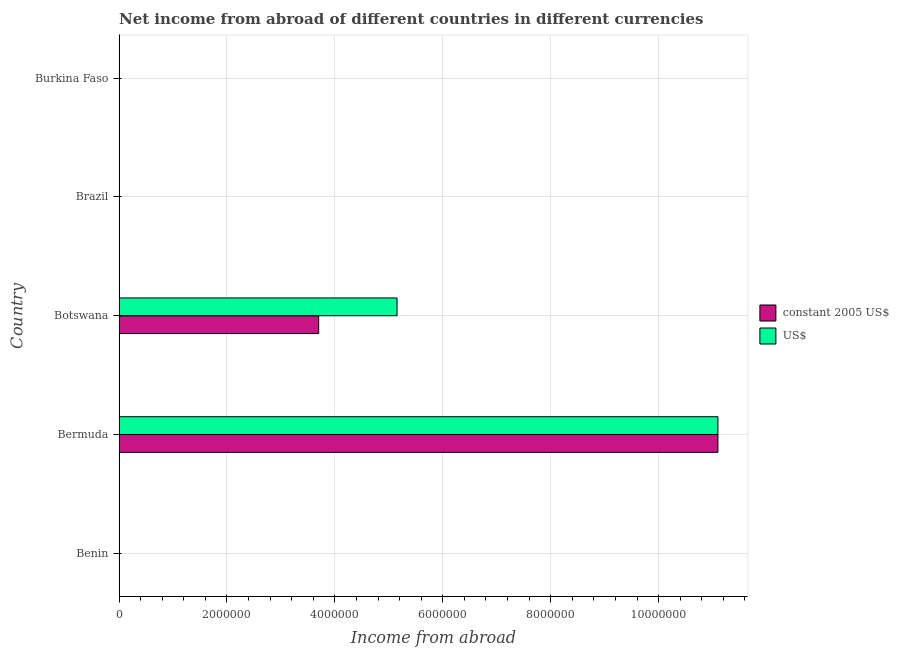How many different coloured bars are there?
Make the answer very short. 2. How many bars are there on the 2nd tick from the top?
Make the answer very short. 0. How many bars are there on the 5th tick from the bottom?
Offer a terse response. 0. What is the label of the 4th group of bars from the top?
Give a very brief answer. Bermuda. What is the income from abroad in us$ in Botswana?
Offer a terse response. 5.15e+06. Across all countries, what is the maximum income from abroad in constant 2005 us$?
Offer a very short reply. 1.11e+07. In which country was the income from abroad in constant 2005 us$ maximum?
Ensure brevity in your answer.  Bermuda. What is the total income from abroad in constant 2005 us$ in the graph?
Keep it short and to the point. 1.48e+07. What is the difference between the income from abroad in constant 2005 us$ in Bermuda and that in Botswana?
Give a very brief answer. 7.40e+06. What is the difference between the income from abroad in us$ in Brazil and the income from abroad in constant 2005 us$ in Burkina Faso?
Your response must be concise. 0. What is the average income from abroad in us$ per country?
Your response must be concise. 3.25e+06. In how many countries, is the income from abroad in constant 2005 us$ greater than 2800000 units?
Offer a terse response. 2. What is the difference between the highest and the lowest income from abroad in us$?
Make the answer very short. 1.11e+07. Does the graph contain any zero values?
Provide a short and direct response. Yes. Does the graph contain grids?
Your answer should be compact. Yes. What is the title of the graph?
Offer a very short reply. Net income from abroad of different countries in different currencies. Does "Fixed telephone" appear as one of the legend labels in the graph?
Offer a very short reply. No. What is the label or title of the X-axis?
Offer a very short reply. Income from abroad. What is the label or title of the Y-axis?
Offer a very short reply. Country. What is the Income from abroad in constant 2005 US$ in Benin?
Your answer should be very brief. 0. What is the Income from abroad of US$ in Benin?
Offer a terse response. 0. What is the Income from abroad in constant 2005 US$ in Bermuda?
Your answer should be very brief. 1.11e+07. What is the Income from abroad in US$ in Bermuda?
Offer a very short reply. 1.11e+07. What is the Income from abroad in constant 2005 US$ in Botswana?
Make the answer very short. 3.70e+06. What is the Income from abroad of US$ in Botswana?
Provide a short and direct response. 5.15e+06. What is the Income from abroad in constant 2005 US$ in Brazil?
Offer a very short reply. 0. What is the Income from abroad of US$ in Burkina Faso?
Provide a short and direct response. 0. Across all countries, what is the maximum Income from abroad in constant 2005 US$?
Your answer should be compact. 1.11e+07. Across all countries, what is the maximum Income from abroad of US$?
Your answer should be very brief. 1.11e+07. Across all countries, what is the minimum Income from abroad of constant 2005 US$?
Ensure brevity in your answer.  0. What is the total Income from abroad in constant 2005 US$ in the graph?
Offer a very short reply. 1.48e+07. What is the total Income from abroad of US$ in the graph?
Provide a succinct answer. 1.63e+07. What is the difference between the Income from abroad in constant 2005 US$ in Bermuda and that in Botswana?
Provide a succinct answer. 7.40e+06. What is the difference between the Income from abroad in US$ in Bermuda and that in Botswana?
Give a very brief answer. 5.95e+06. What is the difference between the Income from abroad in constant 2005 US$ in Bermuda and the Income from abroad in US$ in Botswana?
Your answer should be very brief. 5.95e+06. What is the average Income from abroad in constant 2005 US$ per country?
Offer a very short reply. 2.96e+06. What is the average Income from abroad in US$ per country?
Offer a very short reply. 3.25e+06. What is the difference between the Income from abroad in constant 2005 US$ and Income from abroad in US$ in Bermuda?
Make the answer very short. 0. What is the difference between the Income from abroad of constant 2005 US$ and Income from abroad of US$ in Botswana?
Keep it short and to the point. -1.45e+06. What is the ratio of the Income from abroad in constant 2005 US$ in Bermuda to that in Botswana?
Provide a short and direct response. 3. What is the ratio of the Income from abroad in US$ in Bermuda to that in Botswana?
Your answer should be compact. 2.15. What is the difference between the highest and the lowest Income from abroad of constant 2005 US$?
Offer a very short reply. 1.11e+07. What is the difference between the highest and the lowest Income from abroad of US$?
Offer a very short reply. 1.11e+07. 